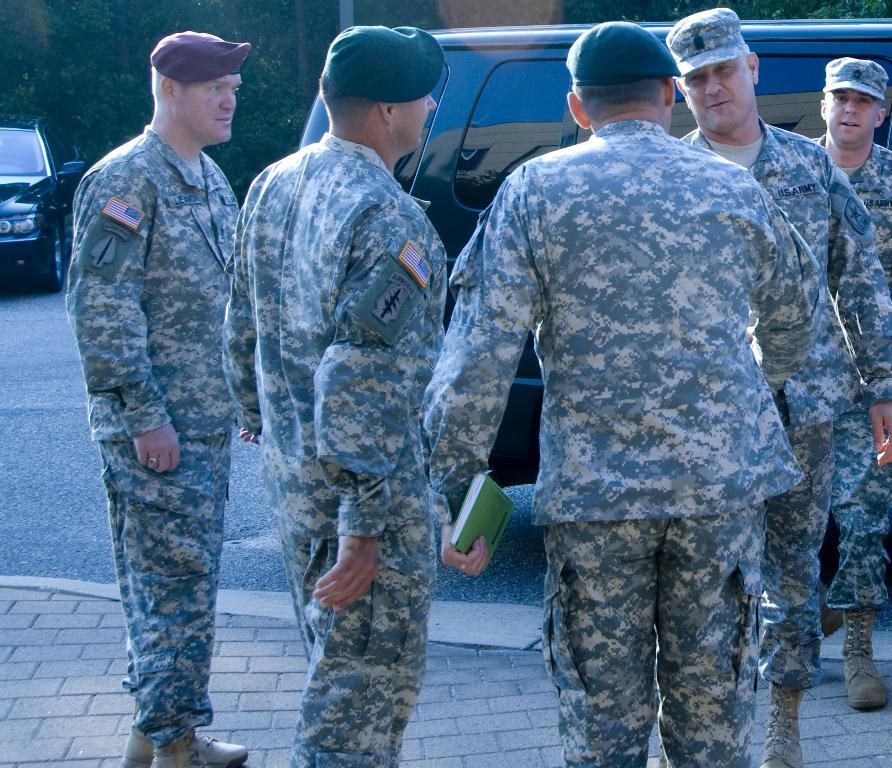What can be seen in the image? There are people standing in the image. What are the people wearing on their heads? The people are wearing caps. What is located on the left side of the image? There is a car on the left side of the image. What can be seen in the background of the image? There are trees in the background of the image. What object is present in the image that is not related to the people or the car? There is a book present in the image. What type of whip is being used by the people in the image? There is no whip present in the image; the people are not using any whips. 